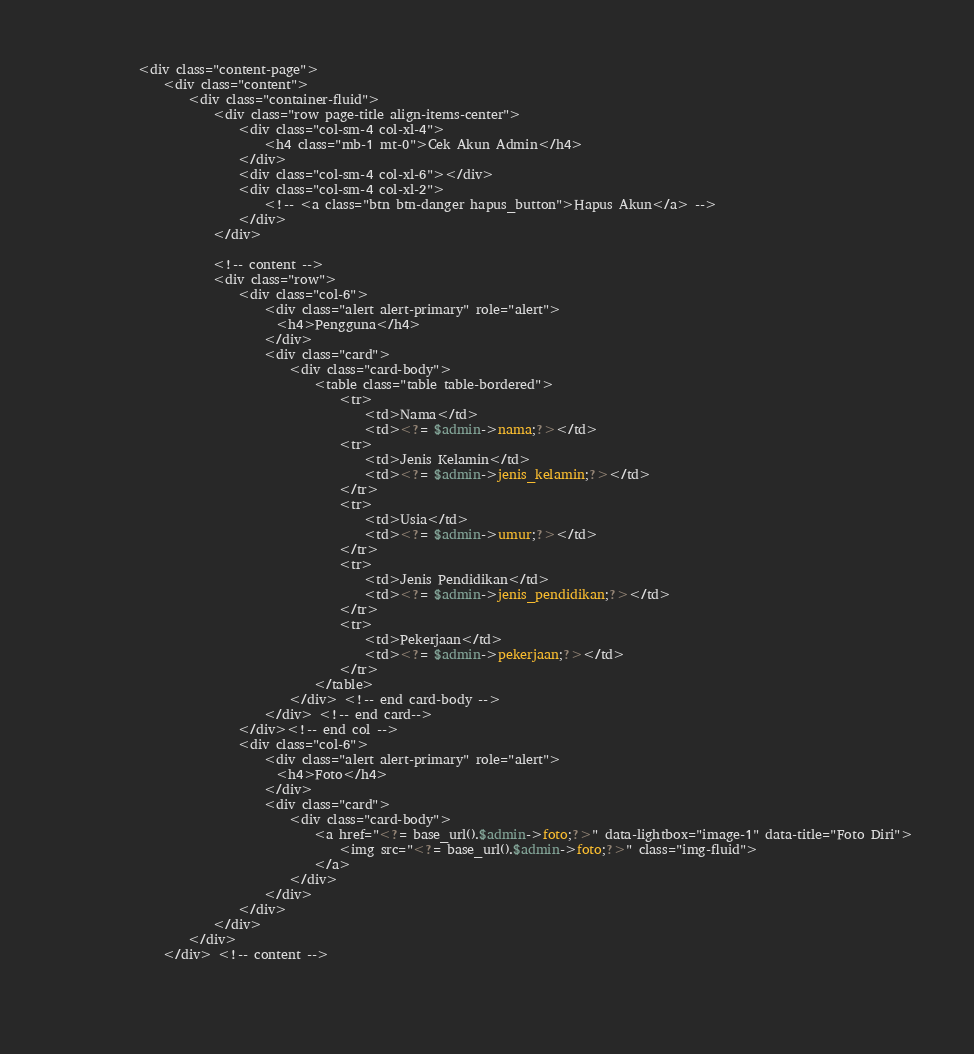Convert code to text. <code><loc_0><loc_0><loc_500><loc_500><_PHP_>            <div class="content-page">
                <div class="content">
                    <div class="container-fluid">
                        <div class="row page-title align-items-center">
                            <div class="col-sm-4 col-xl-4">
                                <h4 class="mb-1 mt-0">Cek Akun Admin</h4>
                            </div>
                            <div class="col-sm-4 col-xl-6"></div>
                            <div class="col-sm-4 col-xl-2">
                                <!-- <a class="btn btn-danger hapus_button">Hapus Akun</a> -->
                            </div>
                        </div>

                        <!-- content -->
                        <div class="row">
                            <div class="col-6">
                            	<div class="alert alert-primary" role="alert">
								  <h4>Pengguna</h4>
								</div>
                                <div class="card">
                                    <div class="card-body">
                                        <table class="table table-bordered">
                                            <tr>
                                                <td>Nama</td>
                                                <td><?= $admin->nama;?></td>
                                            <tr>
                                                <td>Jenis Kelamin</td>
                                                <td><?= $admin->jenis_kelamin;?></td>
                                            </tr>
                                            <tr>
                                                <td>Usia</td>
                                                <td><?= $admin->umur;?></td>
                                            </tr>
                                            <tr>
                                                <td>Jenis Pendidikan</td>
                                                <td><?= $admin->jenis_pendidikan;?></td>
                                            </tr>
                                            <tr>
                                                <td>Pekerjaan</td>
                                                <td><?= $admin->pekerjaan;?></td>
                                            </tr>
                                        </table>
                                    </div> <!-- end card-body -->
                                </div> <!-- end card-->
                            </div><!-- end col -->
                            <div class="col-6">
                            	<div class="alert alert-primary" role="alert">
								  <h4>Foto</h4>
								</div>
                                <div class="card">
                                    <div class="card-body">
                                        <a href="<?= base_url().$admin->foto;?>" data-lightbox="image-1" data-title="Foto Diri">
                                            <img src="<?= base_url().$admin->foto;?>" class="img-fluid">
                                        </a>
                                    </div>
                                </div>
                            </div>
                        </div>
                    </div>
                </div> <!-- content -->

                
</code> 